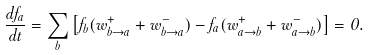<formula> <loc_0><loc_0><loc_500><loc_500>\frac { d f _ { a } } { d t } = \sum _ { b } \left [ f _ { b } ( w ^ { + } _ { b \rightarrow a } + w ^ { - } _ { b \rightarrow a } ) - f _ { a } ( w ^ { + } _ { a \rightarrow b } + w ^ { - } _ { a \rightarrow b } ) \right ] = 0 .</formula> 